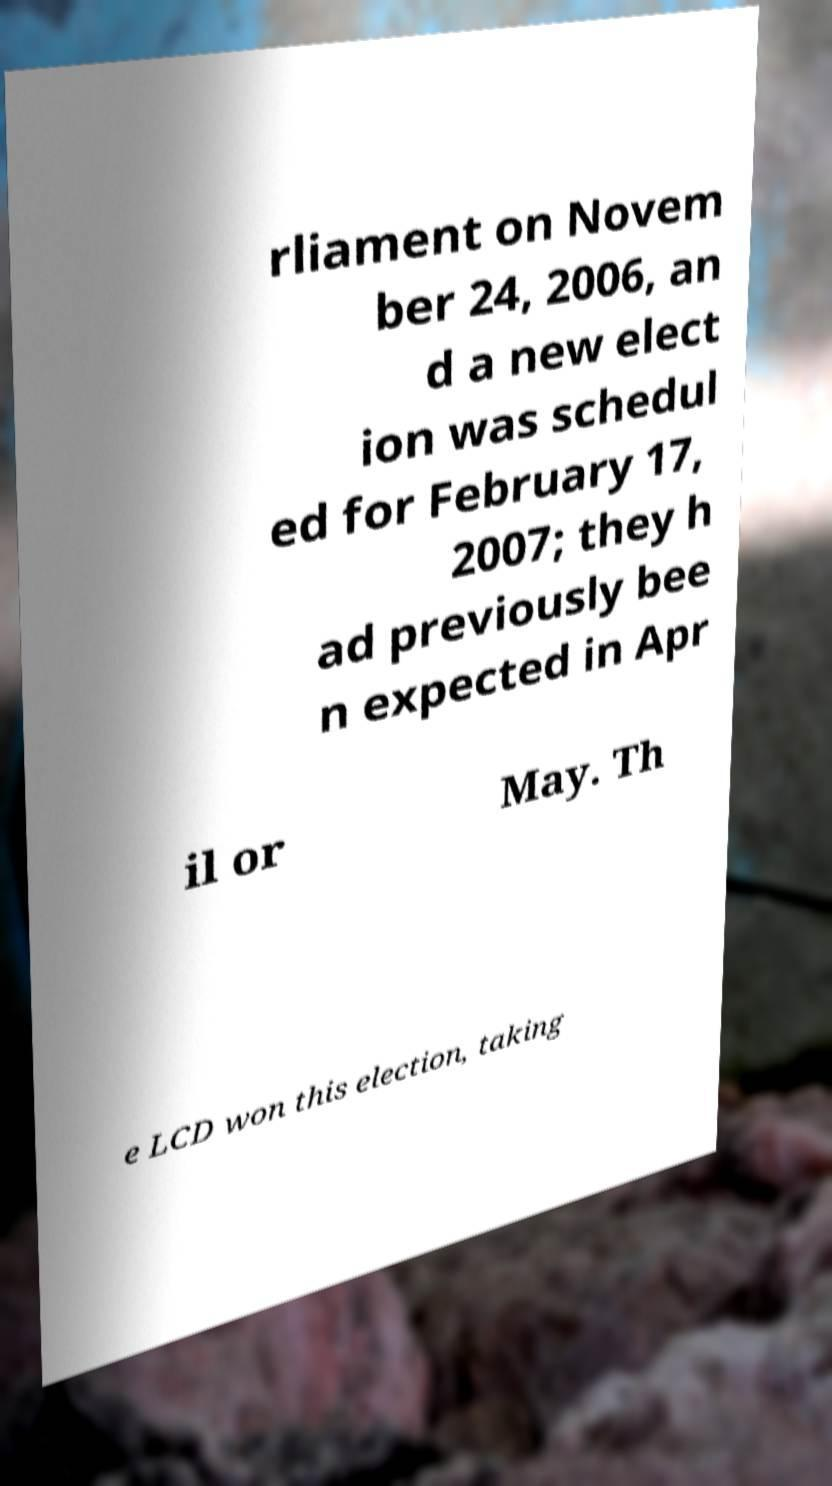There's text embedded in this image that I need extracted. Can you transcribe it verbatim? rliament on Novem ber 24, 2006, an d a new elect ion was schedul ed for February 17, 2007; they h ad previously bee n expected in Apr il or May. Th e LCD won this election, taking 